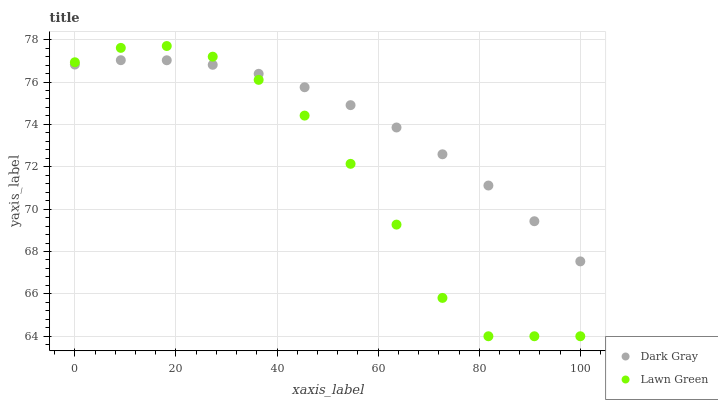Does Lawn Green have the minimum area under the curve?
Answer yes or no. Yes. Does Dark Gray have the maximum area under the curve?
Answer yes or no. Yes. Does Lawn Green have the maximum area under the curve?
Answer yes or no. No. Is Dark Gray the smoothest?
Answer yes or no. Yes. Is Lawn Green the roughest?
Answer yes or no. Yes. Is Lawn Green the smoothest?
Answer yes or no. No. Does Lawn Green have the lowest value?
Answer yes or no. Yes. Does Lawn Green have the highest value?
Answer yes or no. Yes. Does Lawn Green intersect Dark Gray?
Answer yes or no. Yes. Is Lawn Green less than Dark Gray?
Answer yes or no. No. Is Lawn Green greater than Dark Gray?
Answer yes or no. No. 